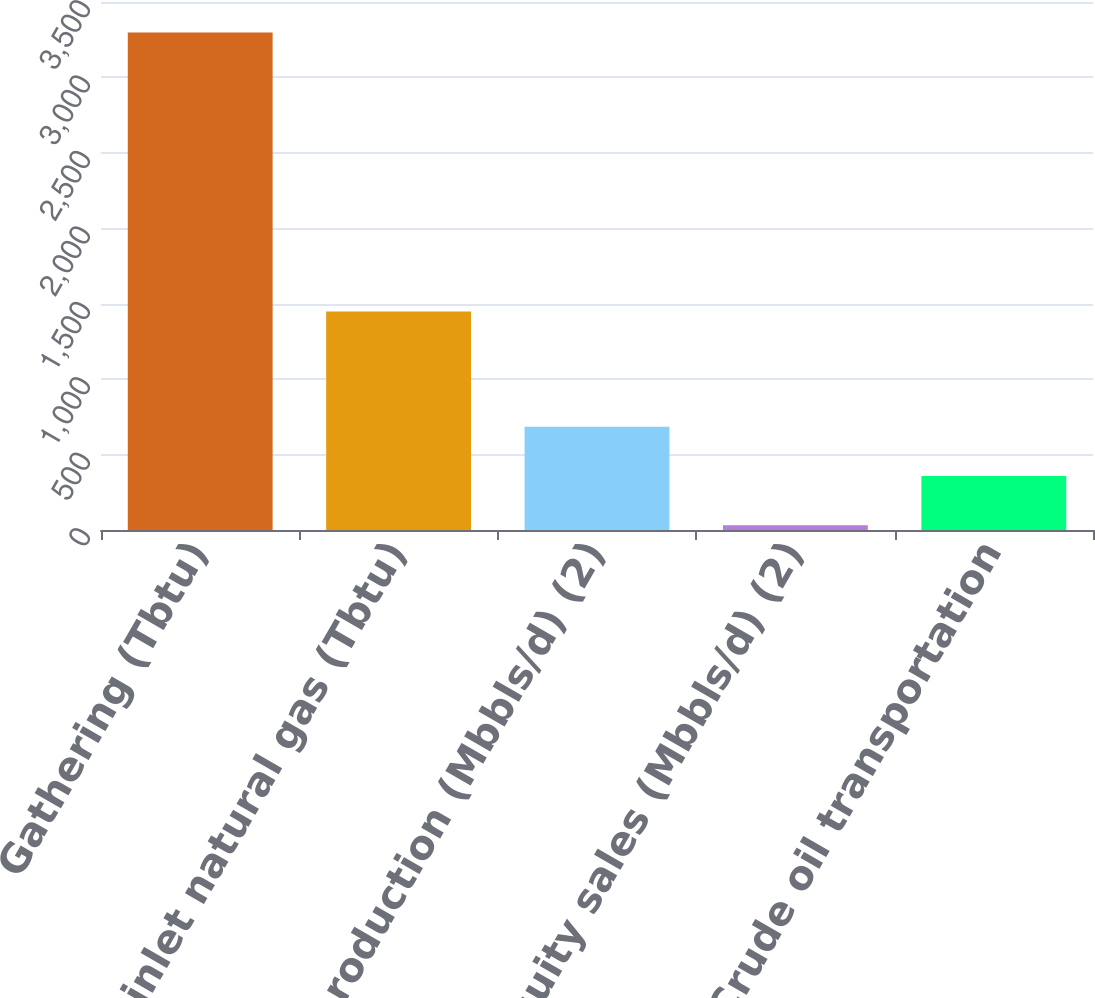Convert chart. <chart><loc_0><loc_0><loc_500><loc_500><bar_chart><fcel>Gathering (Tbtu)<fcel>Plant inlet natural gas (Tbtu)<fcel>NGL production (Mbbls/d) (2)<fcel>NGL equity sales (Mbbls/d) (2)<fcel>Crude oil transportation<nl><fcel>3298<fcel>1448<fcel>684.4<fcel>31<fcel>357.7<nl></chart> 